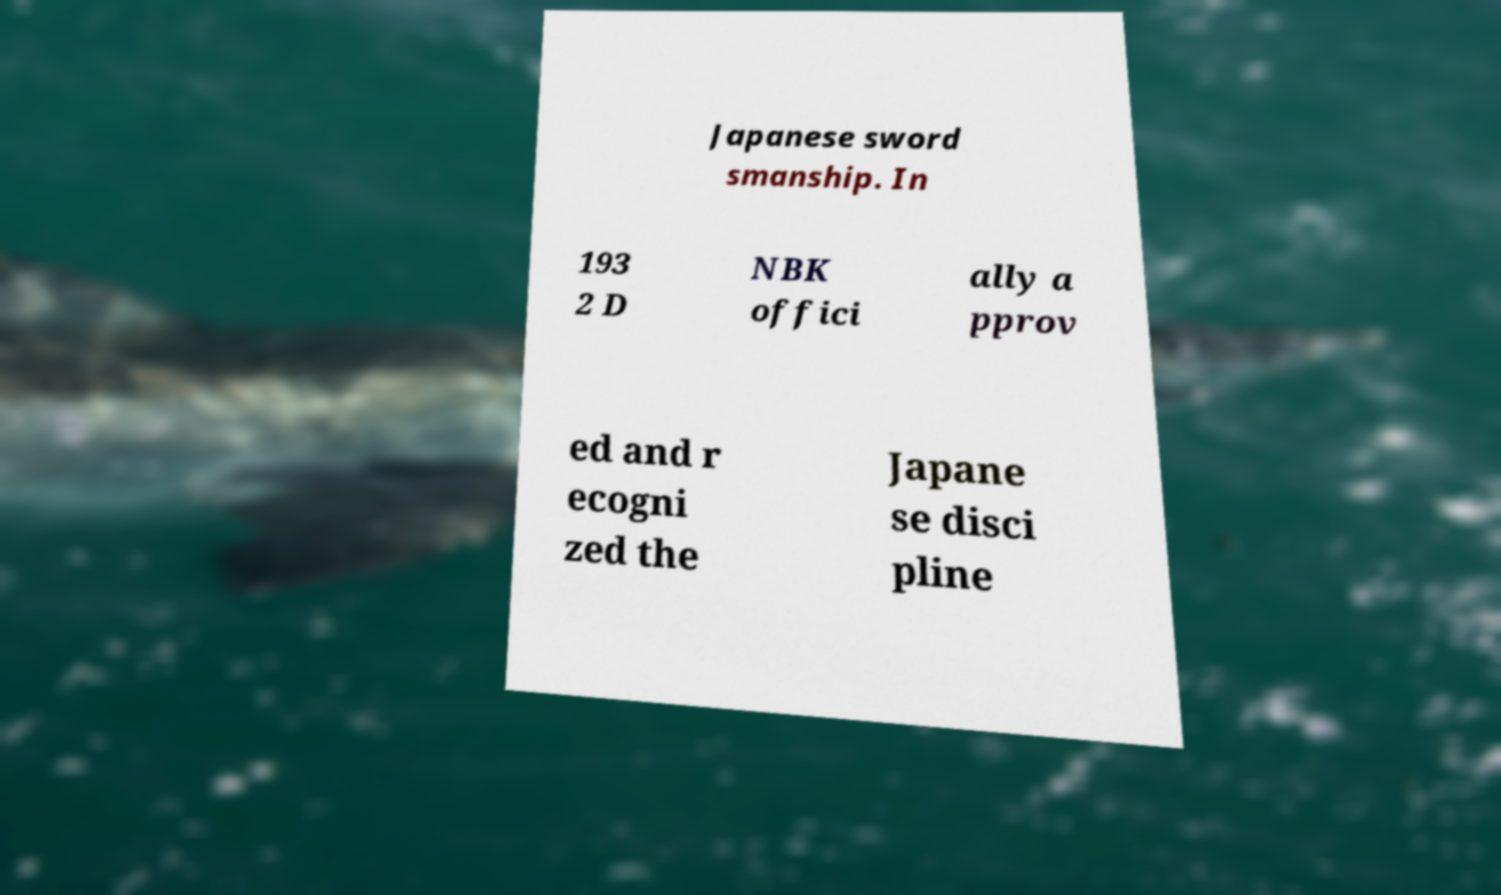What messages or text are displayed in this image? I need them in a readable, typed format. Japanese sword smanship. In 193 2 D NBK offici ally a pprov ed and r ecogni zed the Japane se disci pline 